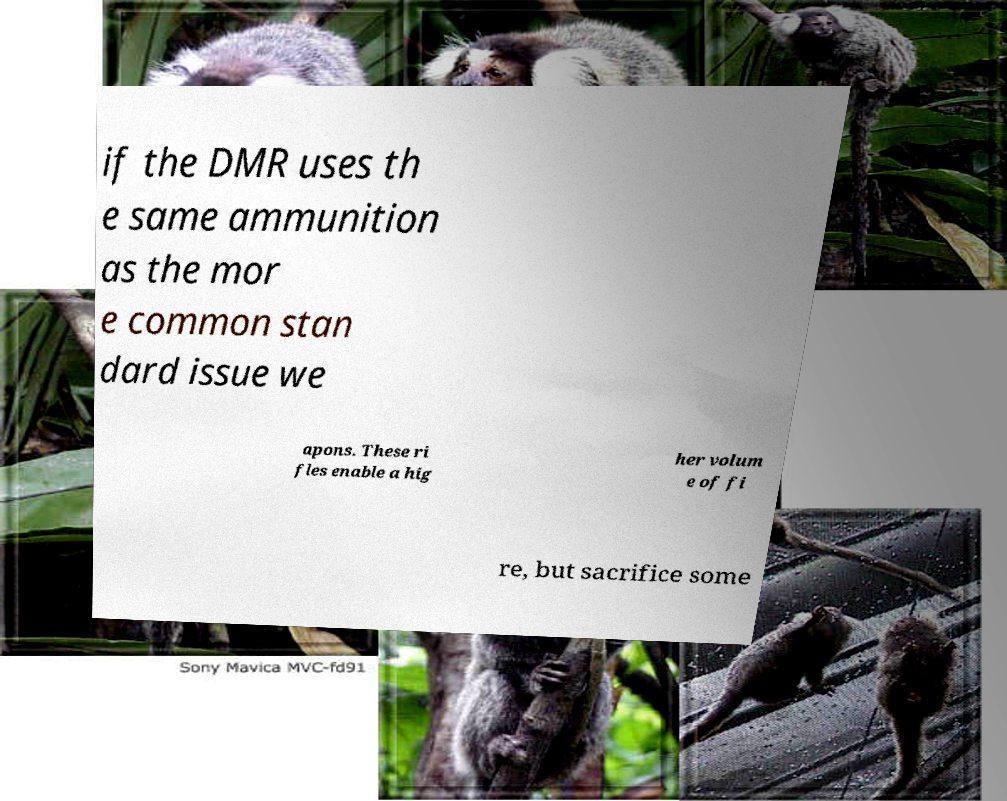Can you read and provide the text displayed in the image?This photo seems to have some interesting text. Can you extract and type it out for me? if the DMR uses th e same ammunition as the mor e common stan dard issue we apons. These ri fles enable a hig her volum e of fi re, but sacrifice some 